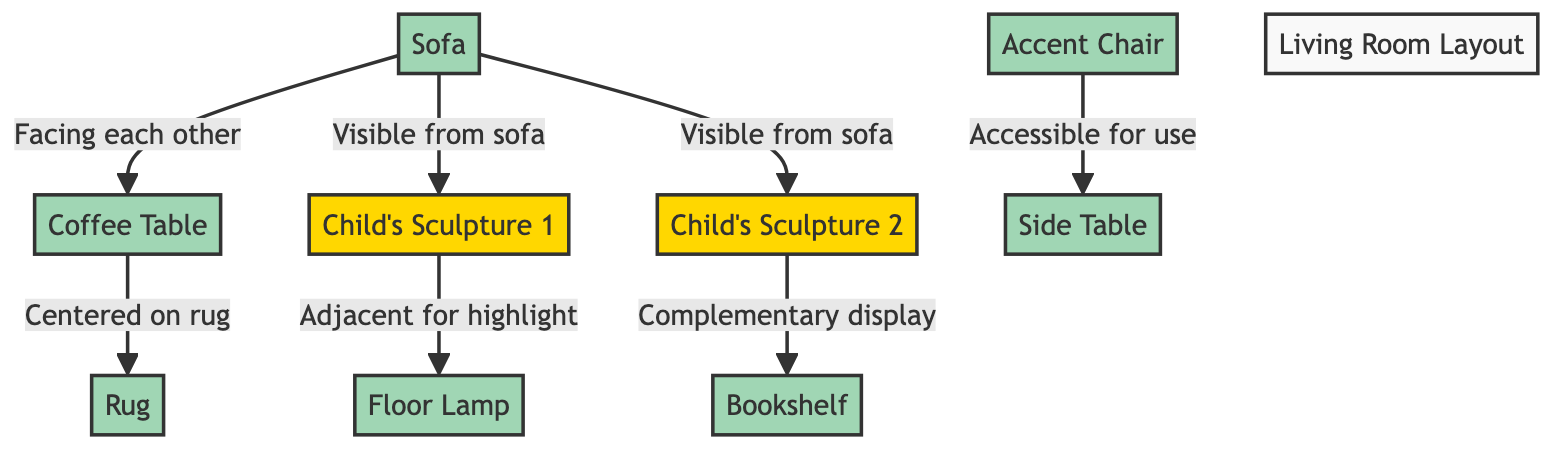What two pieces of furniture are facing each other? The diagram indicates that the sofa and the coffee table are designed to face each other. This is shown by the direct connection labeled "Facing each other."
Answer: sofa and coffee table Which sculpture is adjacent to the floor lamp? According to the diagram, sculpture 1 is directly connected to the floor lamp with the label "Adjacent for highlight." This indicates that the floor lamp is placed next to sculpture 1.
Answer: sculpture 1 How many sculptures are showcased in the diagram? The diagram features two sculptures indicated as sculpture 1 and sculpture 2. Counting these nodes reveals there are two sculptures present in the layout.
Answer: 2 Which piece of furniture is centered on the rug? The diagram specifies that the coffee table is centered on the rug, as indicated by the connection labeled "Centered on rug." This shows that the coffee table is placed right on top of the rug.
Answer: coffee table What is the relationship between sculpture 2 and the bookshelf? The diagram illustrates that sculpture 2 has a complementary display connection to the bookshelf. This means that sculpture 2 is positioned in a way that enhances or relates to the bookshelf visually.
Answer: Complementary display How is the accent chair positioned in relation to the side table? The diagram shows that the accent chair is accessible for use with a direct connection to the side table. This indicates that the accent chair is placed near the side table, allowing for easy access.
Answer: Accessible for use Which furniture connects to the coffee table? The sofa connects to the coffee table, as indicated in the diagram with a direct relationship labeled "Facing each other." This shows that the sofa is directly related to the coffee table.
Answer: sofa Which sculpture is visible from the sofa? The diagram indicates that both sculptures, sculpture 1 and sculpture 2, are visible from the sofa, as shown by the labels connecting them to the sofa. This means both sculptures can be seen while sitting on the sofa.
Answer: sculpture 1 and sculpture 2 